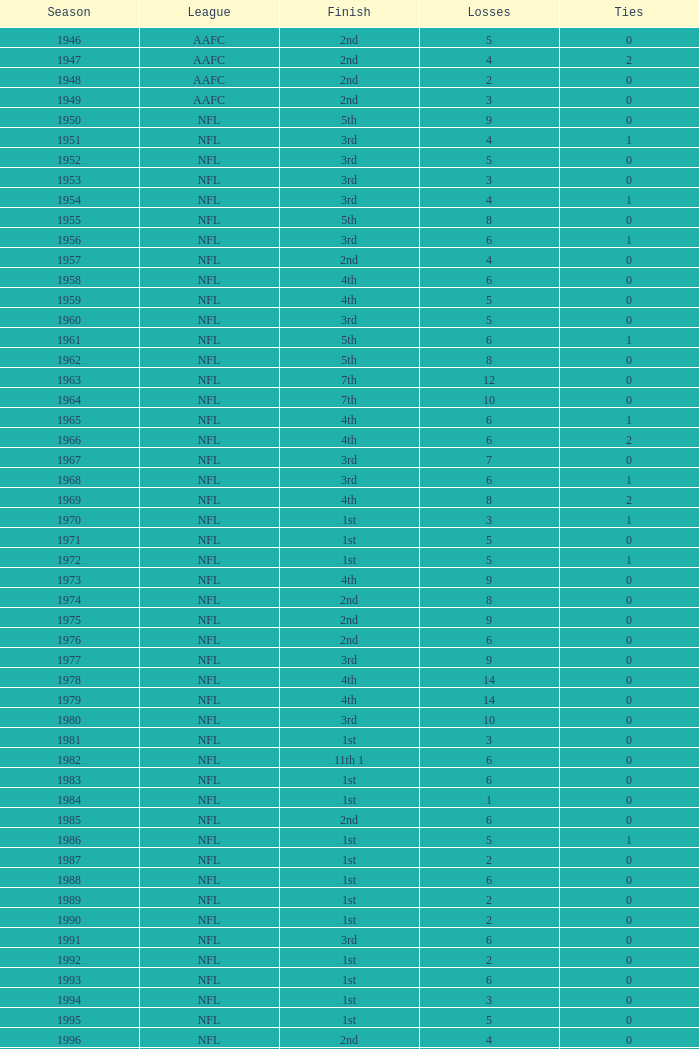What league had a finish of 2nd and 3 losses? AAFC. 